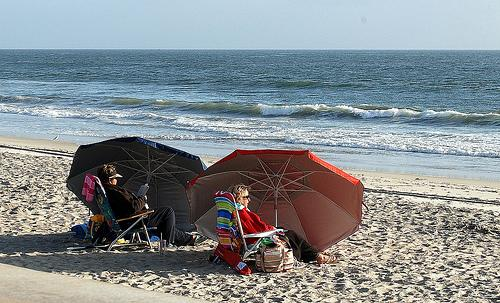Describe the objects placed on the ground at the beach. The objects placed on the ground are beach chairs, beach towels, and umbrellas in the sand. Count the number of people in the image and describe their activities. There are two people in the image - a man and a woman, both sitting in beach chairs. What type of task is this which needs to analyze objects and their interaction in the image? This is an object interaction analysis task. How would you characterize the overall mood or atmosphere of this image? The overall mood of the image is relaxed and leisurely, as it depicts a day at the beach. Looking at the image, what can you say about the overall weather and time of day? The weather appears to be sunny and warm, with a clear blue sky, suggesting daytime. What is the primary focus of this image and what is the setting? The primary focus of the image is people and umbrellas on a beach with ocean, sky, and sand as the setting. Please describe the appearance and location of the ocean waves in this image. The ocean waves appear small and white, crashing near the shoreline, to the left side of the image. Based on the image description, how many clouds can be seen in the sky of the image? There are several white clouds visible against the blue sky, scattered across different parts. Can you identify the colors of the two umbrellas on the beach? The two umbrellas on the beach are navy and red. In this image, are there any accessories or belongings visible with the people? Provide a brief description. Yes, there are striped beach towels on the beach chairs and a sun visor on a person. Can you find the seagull flying above the ocean in the picture? No, it's not mentioned in the image. Find the object that corresponds to "a large red umbrella." Red umbrella at X:182 Y:142 Width:185 Height:185 Which umbrella has a wider coverage area: the navy one or the red one? The red umbrella has a wider coverage area. Rate the quality of the image from 1 (poor) to 10 (excellent). 8 Describe the interaction between the man and woman sitting in beach chairs. The man and woman are seated close to each other under umbrellas, but not directly interacting. Is there a person sitting behind the open navy umbrella? Yes, there is a person sitting behind the open navy umbrella. Identify the color of the umbrella near the coordinates X:53 Y:120. Navy How many clouds are present in the sky? Seven white clouds Identify any text in the image. There is no text in the image. Describe the color and pattern of the ocean water. Blue and white with small waves Describe the scene in the image. The image shows a sandy beach with a navy and a red umbrella, a man and a woman sitting in beach chairs, crashing waves, and a clear blue sky with white clouds. Notice the family playing with a beach ball near the water's edge. The provided information does not mention a family or a beach ball. This instruction falsely implies that there is a group of people engaged in a recreational activity, which is not present in the image. List the attributes of the red umbrella. Large, open, protective shade, on the sand What type of hat is worn by the person at X:107 Y:168? A sun visor What is the sentiment conveyed by the image? Positive and relaxing What is the ground material of the beach? Tan sand What are the colors of the multicolored beach chair? Cannot determine all colors, but at least red is present. State the weather conditions depicted in the image. Clear, sunny day with a few white clouds in the blue sky Detect any anomaly in the image. No anomalies detected. Identify distinct regions in the image based on their semantic meaning. Sky, ocean, sand, umbrellas, beach chairs, people, clouds, and waves What is the object located at X:241 Y:193? Dark black sunglasses 